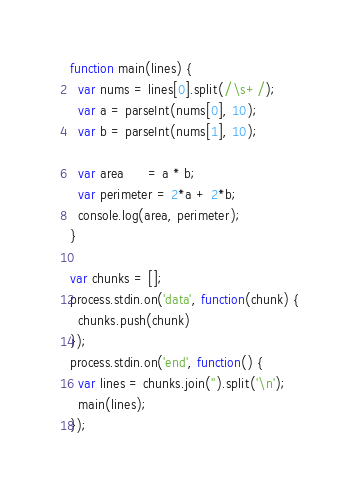<code> <loc_0><loc_0><loc_500><loc_500><_JavaScript_>function main(lines) {
  var nums = lines[0].split(/\s+/);
  var a = parseInt(nums[0], 10);
  var b = parseInt(nums[1], 10);

  var area      = a * b;
  var perimeter = 2*a + 2*b;
  console.log(area, perimeter);
}

var chunks = [];
process.stdin.on('data', function(chunk) {
  chunks.push(chunk)
});
process.stdin.on('end', function() {
  var lines = chunks.join('').split('\n');
  main(lines);
});</code> 